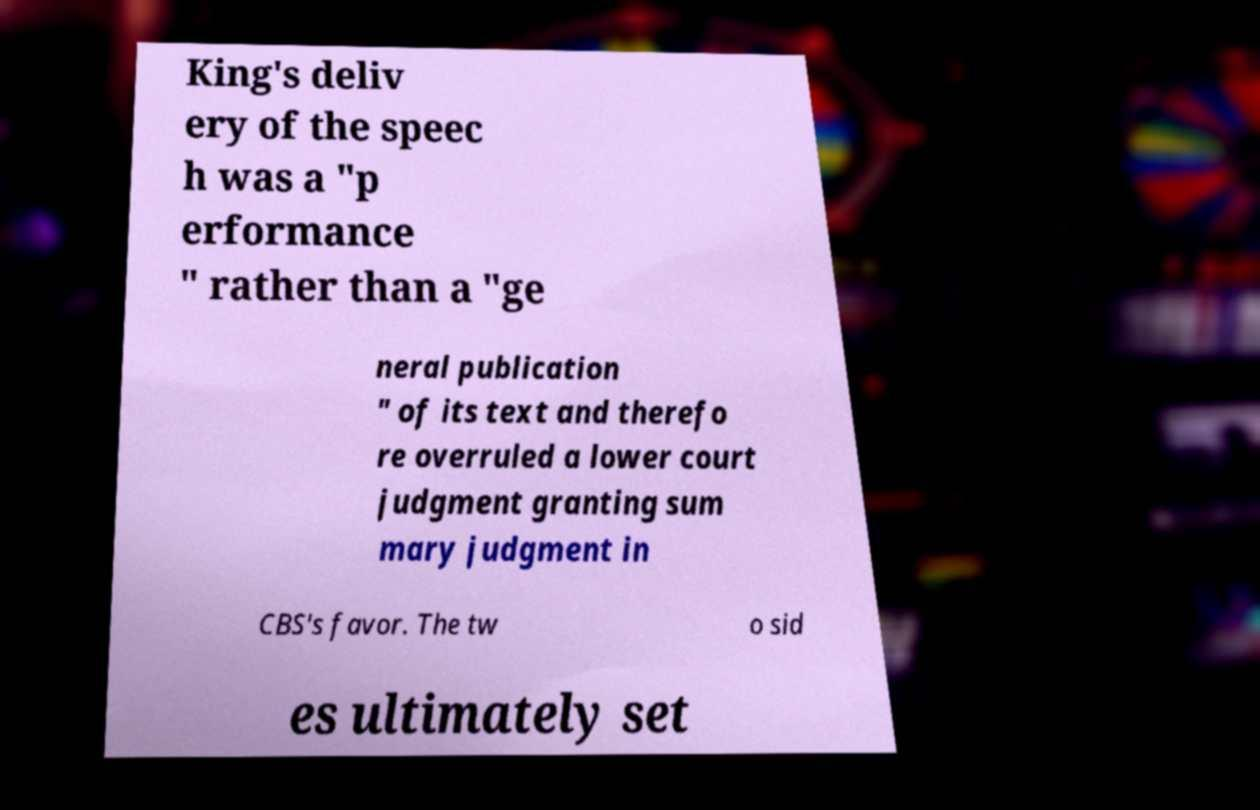There's text embedded in this image that I need extracted. Can you transcribe it verbatim? King's deliv ery of the speec h was a "p erformance " rather than a "ge neral publication " of its text and therefo re overruled a lower court judgment granting sum mary judgment in CBS's favor. The tw o sid es ultimately set 